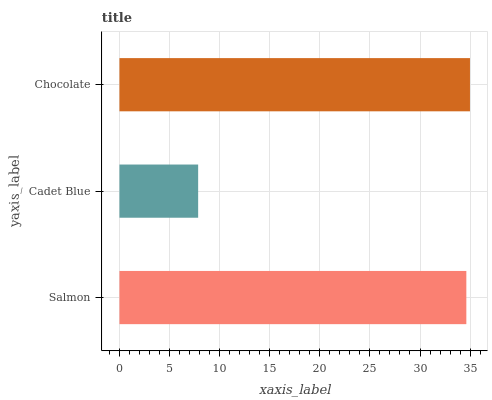Is Cadet Blue the minimum?
Answer yes or no. Yes. Is Chocolate the maximum?
Answer yes or no. Yes. Is Chocolate the minimum?
Answer yes or no. No. Is Cadet Blue the maximum?
Answer yes or no. No. Is Chocolate greater than Cadet Blue?
Answer yes or no. Yes. Is Cadet Blue less than Chocolate?
Answer yes or no. Yes. Is Cadet Blue greater than Chocolate?
Answer yes or no. No. Is Chocolate less than Cadet Blue?
Answer yes or no. No. Is Salmon the high median?
Answer yes or no. Yes. Is Salmon the low median?
Answer yes or no. Yes. Is Chocolate the high median?
Answer yes or no. No. Is Chocolate the low median?
Answer yes or no. No. 